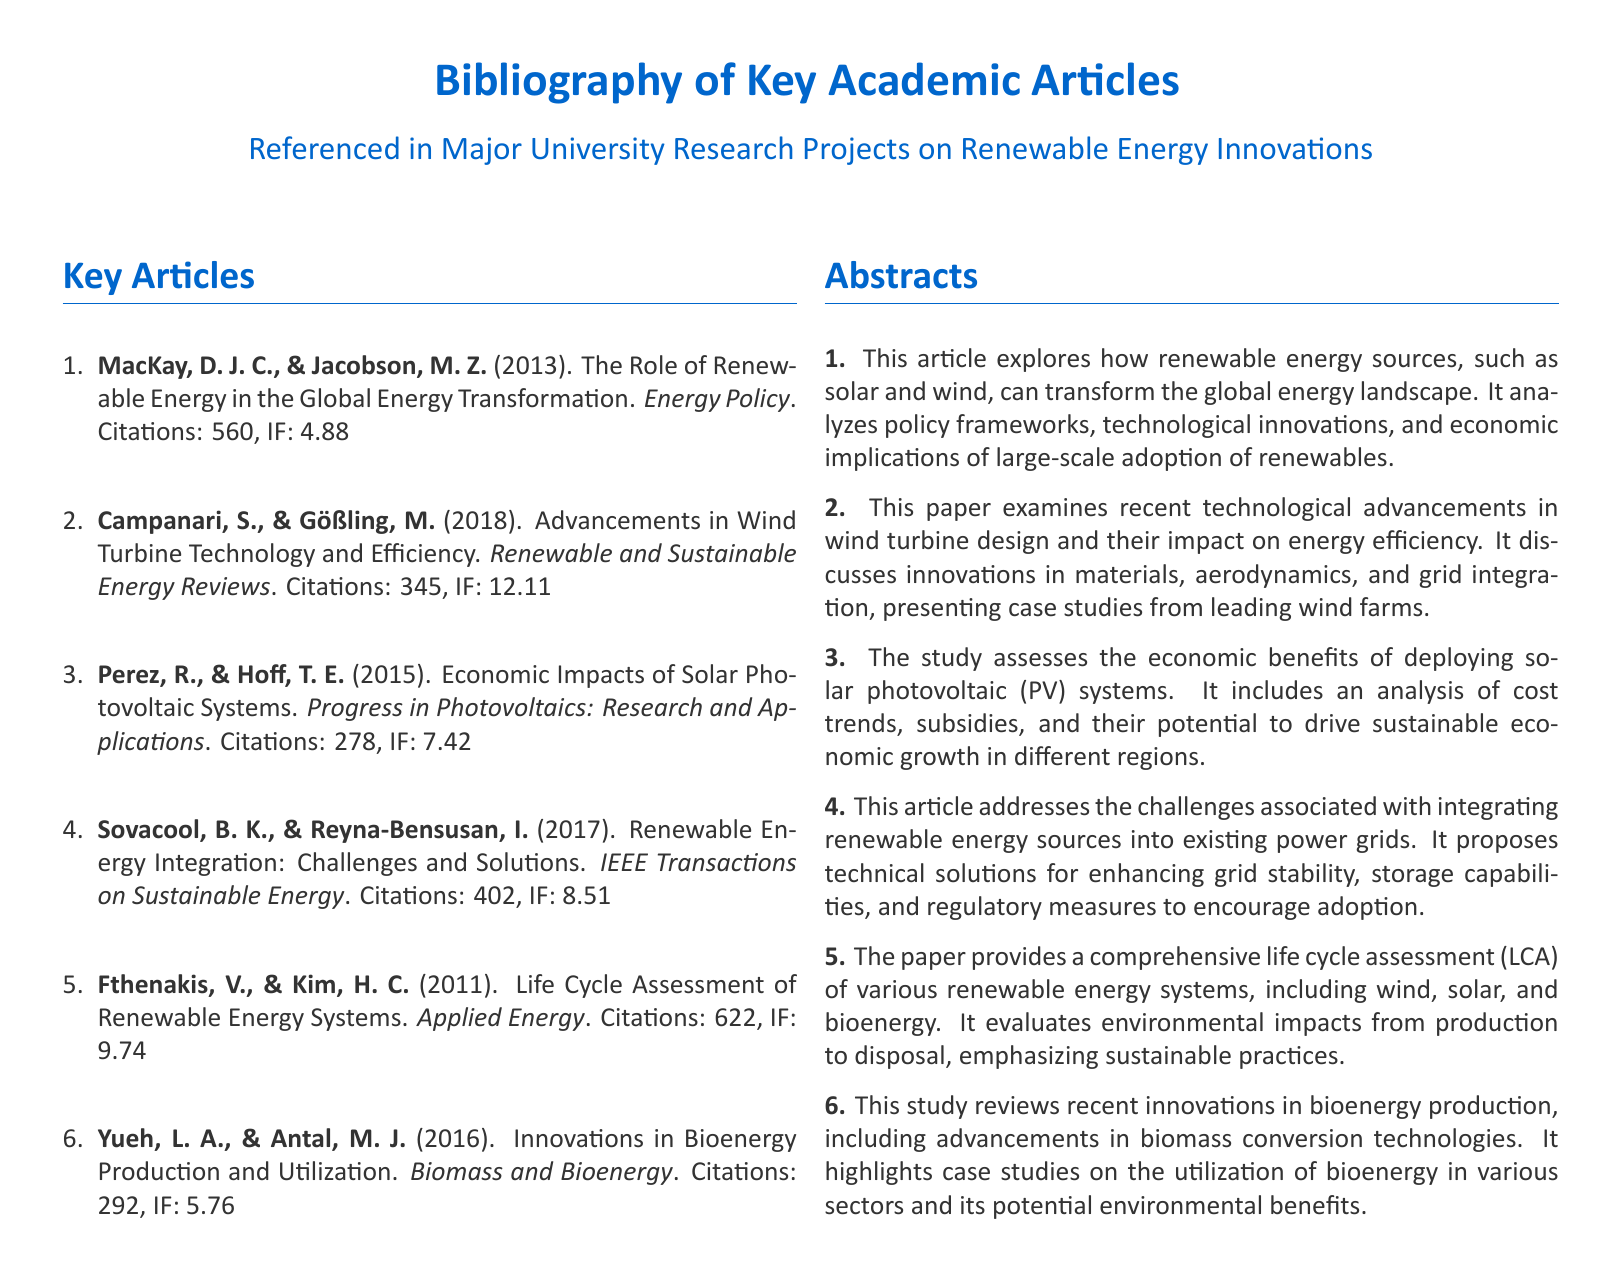What is the citation count for Fthenakis and Kim's article? The citation count for their article is detailed in the document.
Answer: 622 What year was the article by Perez and Hoff published? The publication year is specified in the bibliographic entry.
Answer: 2015 Which journal published the article on advancements in wind turbine technology? The document specifies the journal where this article was published.
Answer: Renewable and Sustainable Energy Reviews How many citations does the article by Sovacool and Reyna-Bensusan have? The citation details are included in the bibliography.
Answer: 402 What is the impact factor of the publication by Campanari and Gößling? The impact factor is given in the document for that article.
Answer: 12.11 Which article discusses life cycle assessment of renewable energy systems? The document lists this article in the key articles section.
Answer: Fthenakis, V., & Kim, H. C Which renewable energy topic has the least citations among the listed articles? This requires comparing the citation counts provided in the document.
Answer: Innovations in Bioenergy Production and Utilization What is the main focus of the article by MacKay and Jacobson? The abstract outlines the focus of their article.
Answer: Global energy transformation What type of document is this bibliography? The structure and content indicate the type of document it is.
Answer: Bibliography 